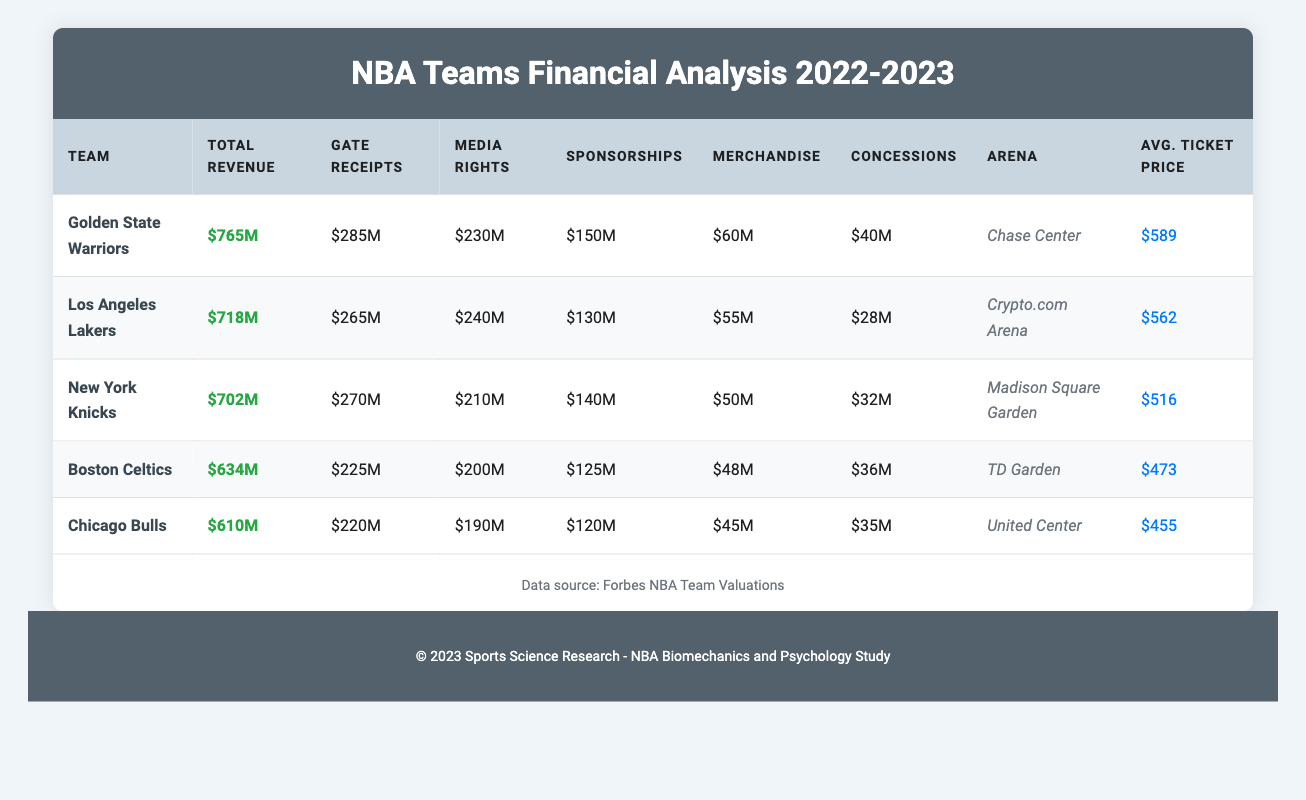What is the total revenue of the Golden State Warriors? The total revenue for the Golden State Warriors is listed in the table under "Total Revenue," which shows the value as 765 million USD.
Answer: 765 million USD Which NBA team has the highest media rights revenue? By comparing the "Media Rights" column for each team, it can be seen that the Los Angeles Lakers have the highest media rights revenue at 240 million USD.
Answer: Los Angeles Lakers What is the combined total revenue of the Boston Celtics and Chicago Bulls? The total revenue for the Boston Celtics is 634 million USD and for the Chicago Bulls is 610 million USD. Adding these together gives 634 + 610 = 1244 million USD.
Answer: 1244 million USD Are the sponsorship revenues for the New York Knicks greater than those for the Chicago Bulls? The New York Knicks have sponsorship revenues of 140 million USD, while the Chicago Bulls have 120 million USD. Since 140 is greater than 120, the statement is true.
Answer: Yes What is the average ticket price for the top three teams by total revenue? The average ticket prices for the top three teams are 589 for the Warriors, 562 for the Lakers, and 516 for the Knicks. To find the average: (589 + 562 + 516) / 3 = 555.67 million USD, which we can round to 556 million USD for simplicity.
Answer: 556 million USD Which team has the lowest revenue from concessions? The table shows that the Chicago Bulls have the lowest revenue from concessions at 35 million USD, compared to other teams.
Answer: Chicago Bulls How does the average ticket price of the Golden State Warriors compare to the Boston Celtics? The average ticket price for the Golden State Warriors is 589 million USD, while for the Boston Celtics it is 473 million USD. Comparing these amounts, 589 is greater than 473, meaning the Warriors have a higher average ticket price.
Answer: Higher What is the total revenue difference between the Los Angeles Lakers and New York Knicks? The total revenue for the Los Angeles Lakers is 718 million USD, and for the New York Knicks, it is 702 million USD. The difference can be calculated as 718 - 702 = 16 million USD.
Answer: 16 million USD What are the total gate receipts for all five teams combined? The gate receipts are as follows: 285 for the Warriors, 265 for the Lakers, 270 for the Knicks, 225 for the Celtics, and 220 for the Bulls. Adding them gives: 285 + 265 + 270 + 225 + 220 = 1265 million USD.
Answer: 1265 million USD 